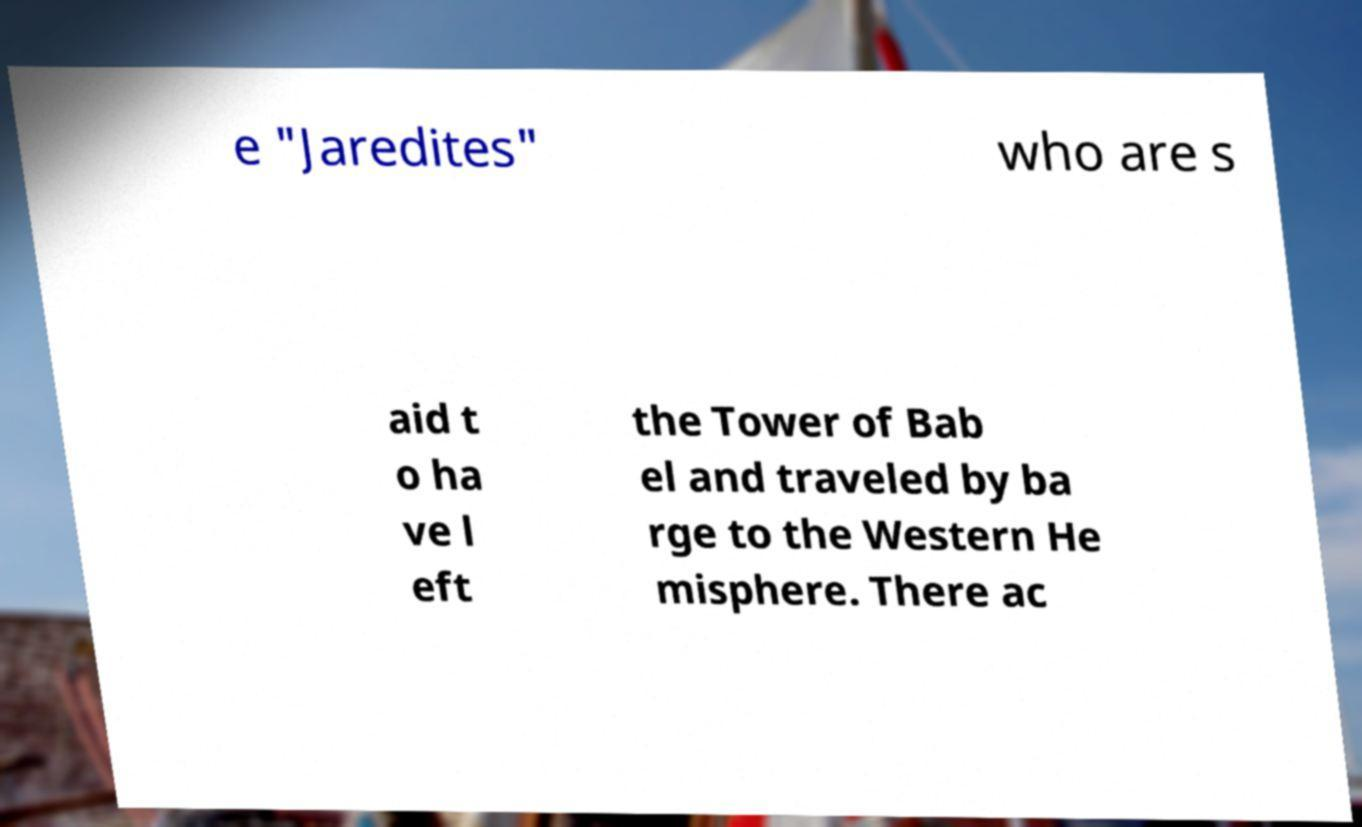For documentation purposes, I need the text within this image transcribed. Could you provide that? e "Jaredites" who are s aid t o ha ve l eft the Tower of Bab el and traveled by ba rge to the Western He misphere. There ac 